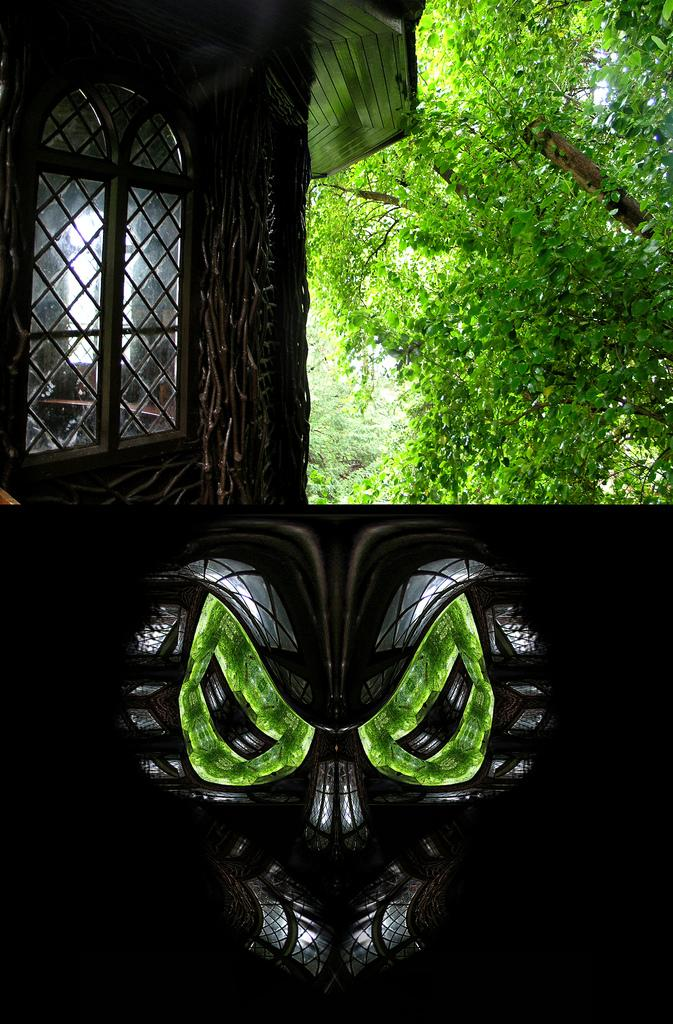What type of artwork is depicted in the image? The image appears to be a collage. What specific item can be seen in the collage? There is a face mask in the image. What type of structure is visible in the collage? There is a building with a window in the image. What type of natural elements are present in the collage? Trees are present in the image. What type of plastic is used to make the pocket in the image? There is no pocket present in the image, so it is not possible to determine the type of plastic used. 